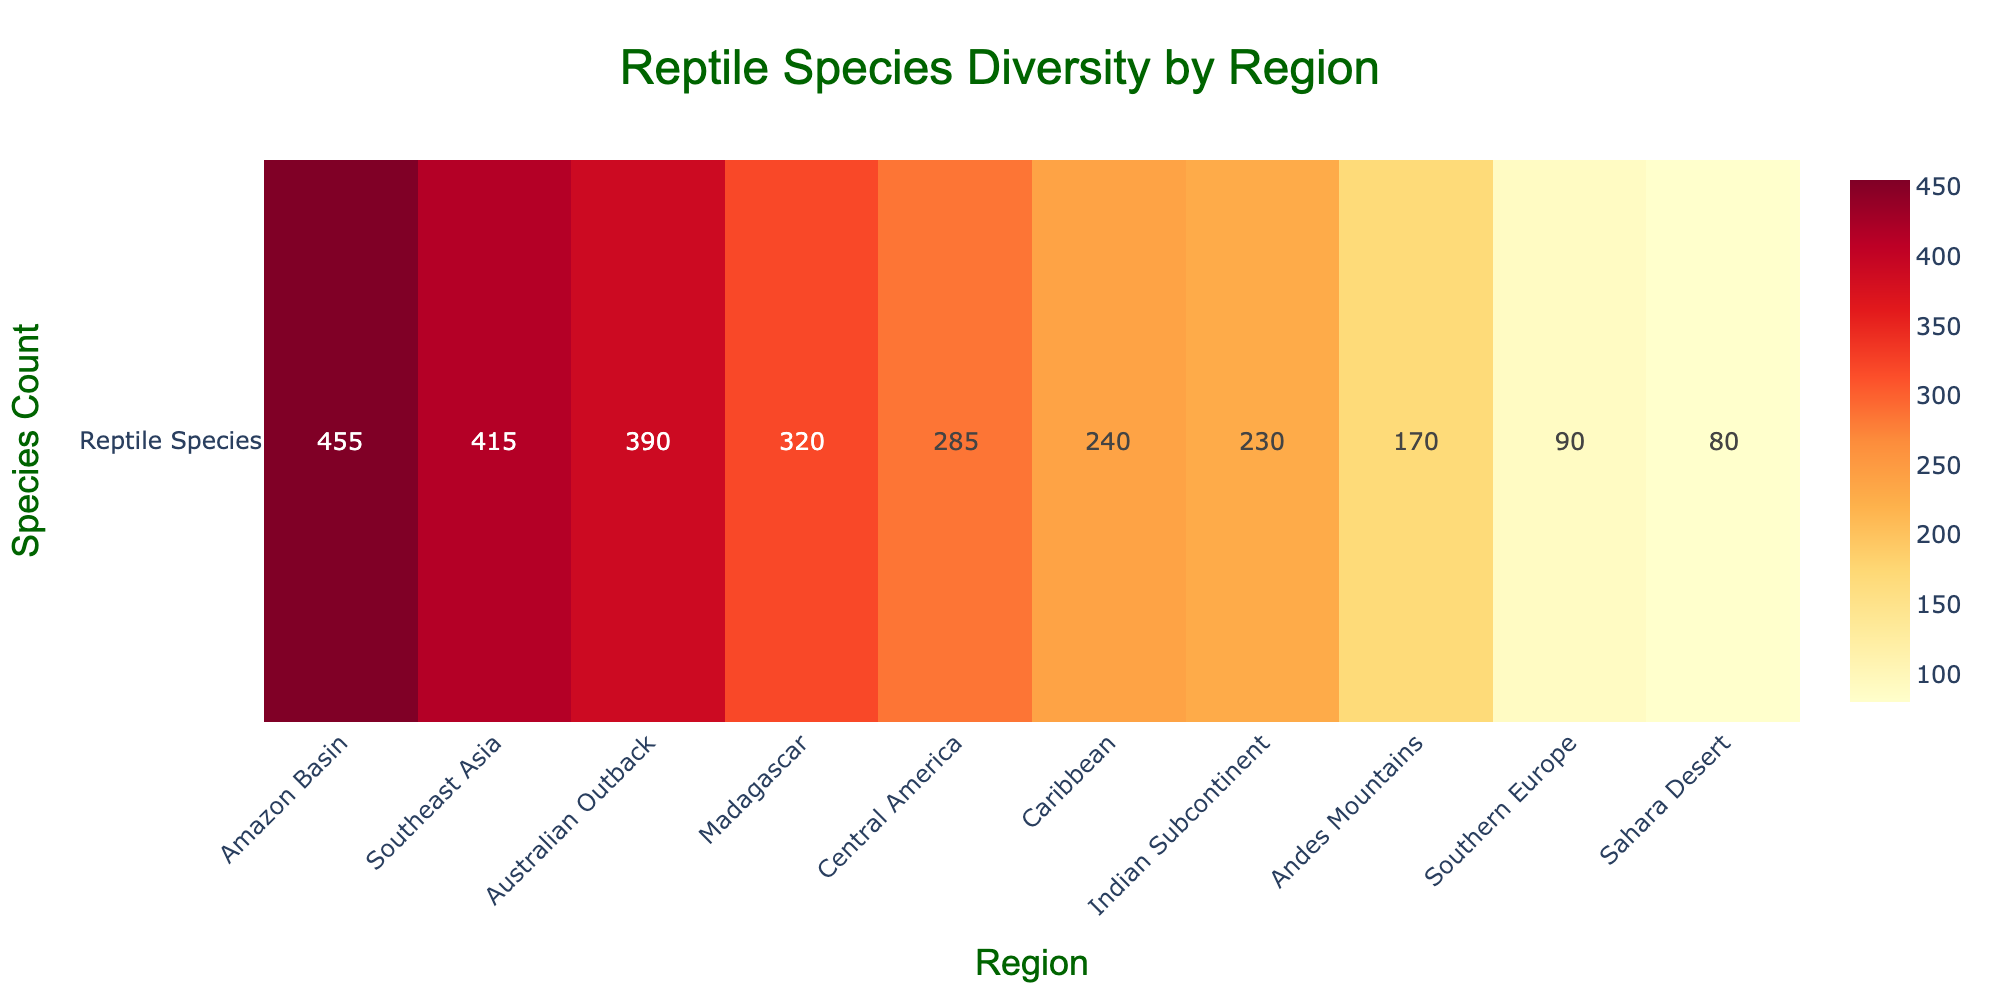Which region has the highest number of reptile species? The title mentions reptile species diversity by region, and the figure shows various regions along the x-axis. By identifying the region with the highest bar, we see that the Amazon Basin has the highest number of reptile species.
Answer: Amazon Basin How many reptile species are in the Australian Outback? The figure lists the number of reptile species by region, with each region labeled on the x-axis and the species count displayed in the cells. The Australian Outback shows a count of 390 reptile species.
Answer: 390 What's the total number of reptile species in the Amazon Basin and Southeast Asia regions combined? First, identify the number of reptile species in the Amazon Basin and Southeast Asia from the figure (455 and 415, respectively). Then sum these numbers: 455 + 415 = 870.
Answer: 870 Which region has fewer reptile species, the Andes Mountains or Southern Europe? The figure shows the number of reptile species by region on the x-axis. The Andes Mountains have 170 species, and Southern Europe has 90. Therefore, Southern Europe has fewer species.
Answer: Southern Europe What is the difference in the number of reptile species between Madagascar and the Caribbean? Find the number of reptile species in Madagascar and the Caribbean in the figure. Madagascar has 320 species, and the Caribbean has 240. The difference is 320 - 240 = 80.
Answer: 80 Are there more reptile species in Central America or the Indian Subcontinent? Identify the number of reptile species for Central America (285) and the Indian Subcontinent (230) from the figure. Central America has more reptile species.
Answer: Central America Which region has the lowest number of reptile species? By looking at the region with the smallest count in the heatmap, we see that the Sahara Desert has the fewest number of reptile species with 80.
Answer: Sahara Desert What's the average number of reptile species across all listed regions? Sum all the species counts from the heatmap: 455 + 390 + 80 + 320 + 415 + 285 + 170 + 230 + 90 + 240 = 2675. Divide by the number of regions (10): 2675 / 10 = 267.5.
Answer: 267.5 Which regions have more than 300 reptile species? By examining the heatmap, the regions with more than 300 reptile species are the Amazon Basin (455), Australian Outback (390), Southeast Asia (415), and Madagascar (320).
Answer: Amazon Basin, Australian Outback, Southeast Asia, Madagascar 